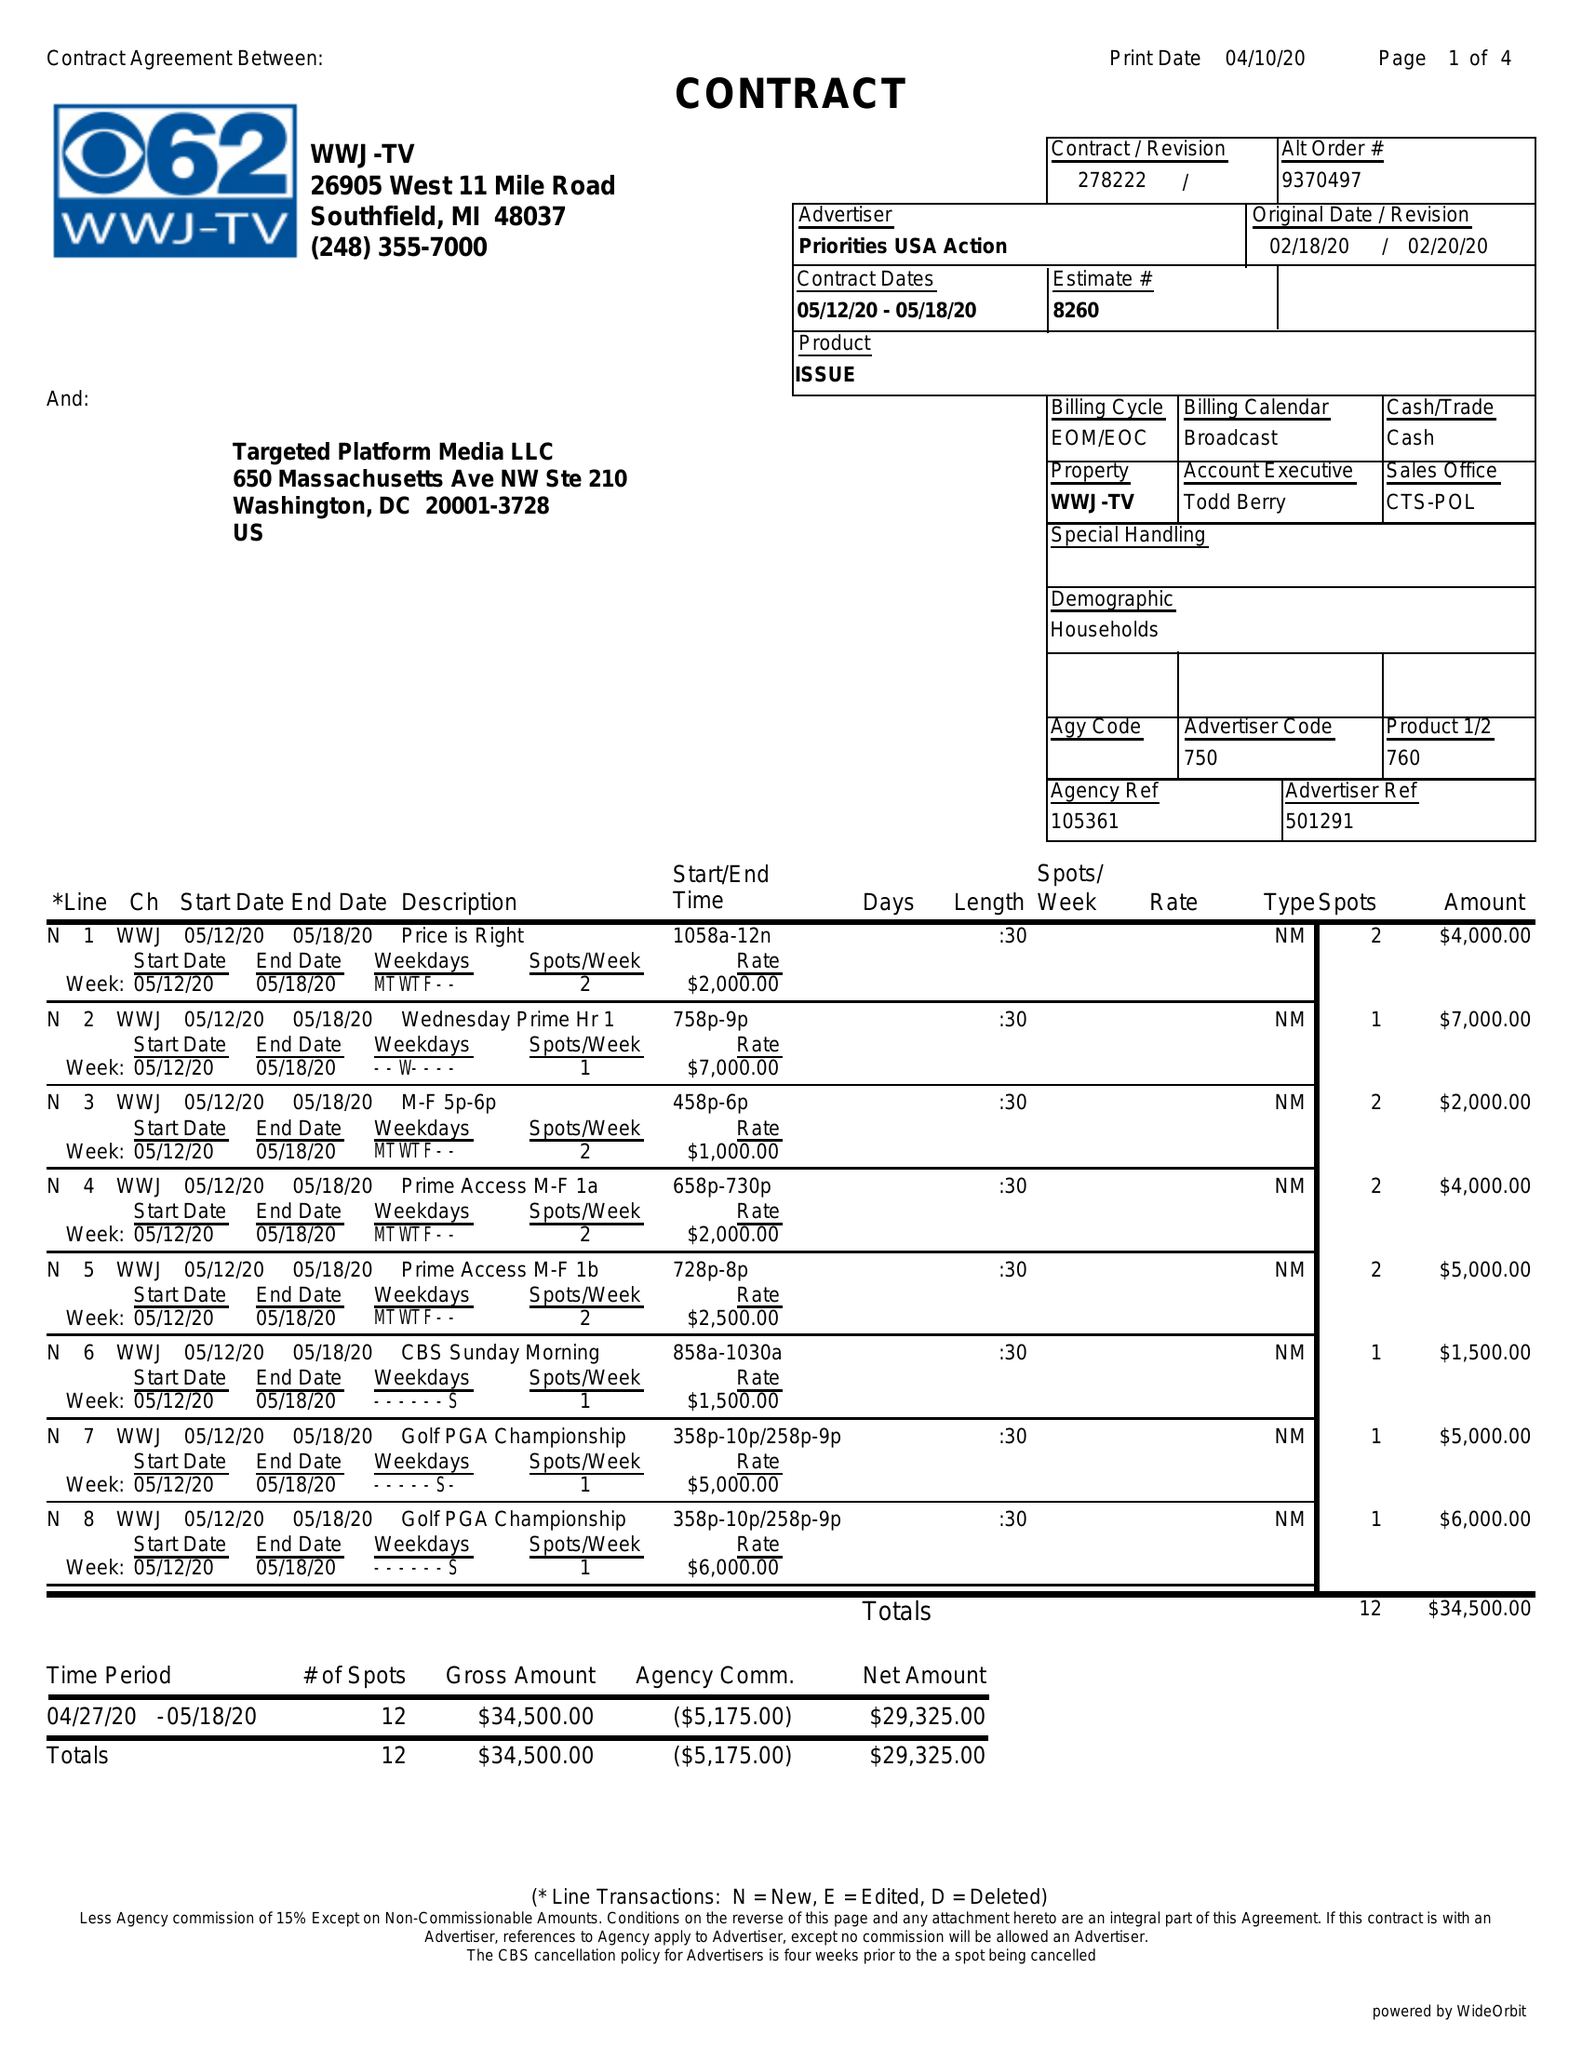What is the value for the contract_num?
Answer the question using a single word or phrase. 278222 